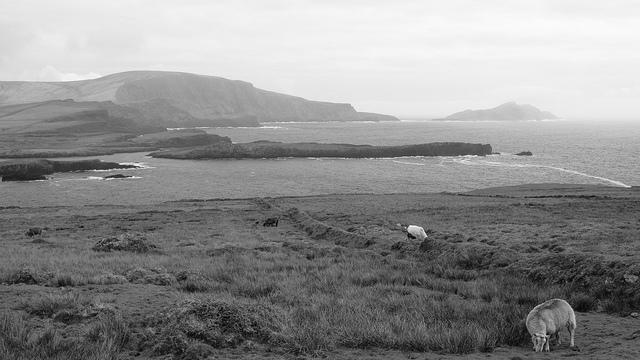What kind of an area is this?

Choices:
A) metropolitan
B) coastal
C) desert
D) jungle coastal 